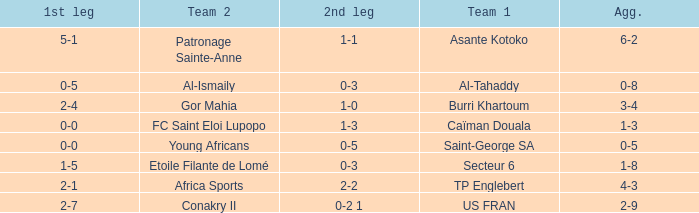Which team lost 0-3 and 0-5? Al-Tahaddy. 